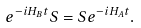Convert formula to latex. <formula><loc_0><loc_0><loc_500><loc_500>e ^ { - i H _ { B } t } S = S e ^ { - i H _ { A } t } .</formula> 